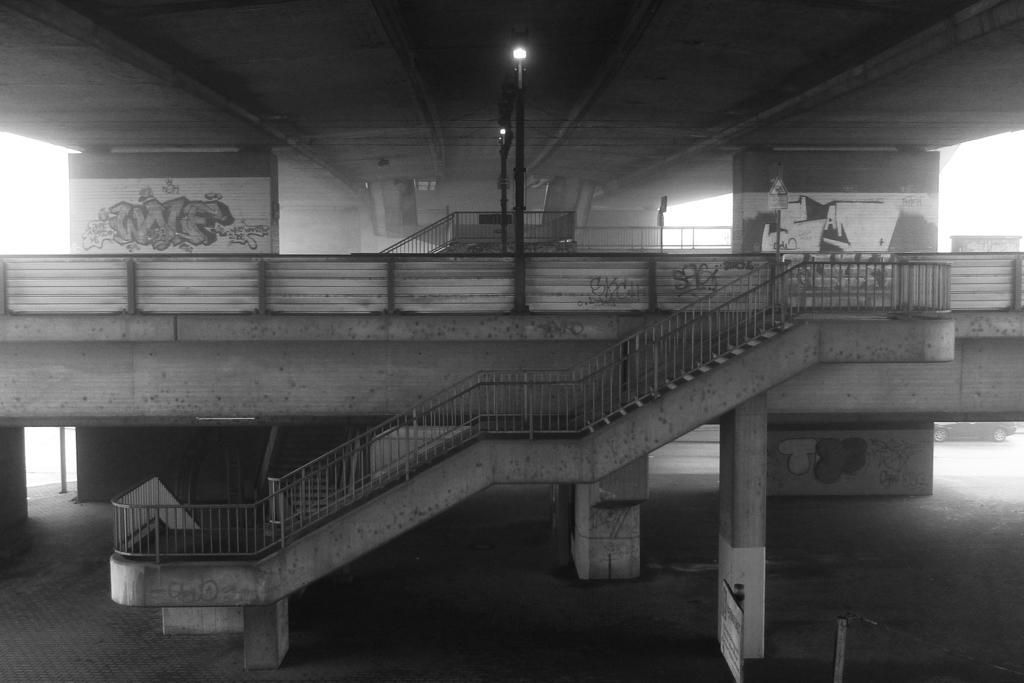What is the color scheme of the image? The image is black and white. What architectural feature can be seen in the image? There are stairs in the image. What is present at the top of the stairs? There are lights at the top of the stairs. What supports the stairs at the bottom? There are pillars at the bottom of the stairs. What type of cushion can be seen on the stairs in the image? There is no cushion present on the stairs in the image. What kind of bird is perched on the pillar at the bottom of the stairs? There is no bird present on the pillar at the bottom of the stairs in the image. 